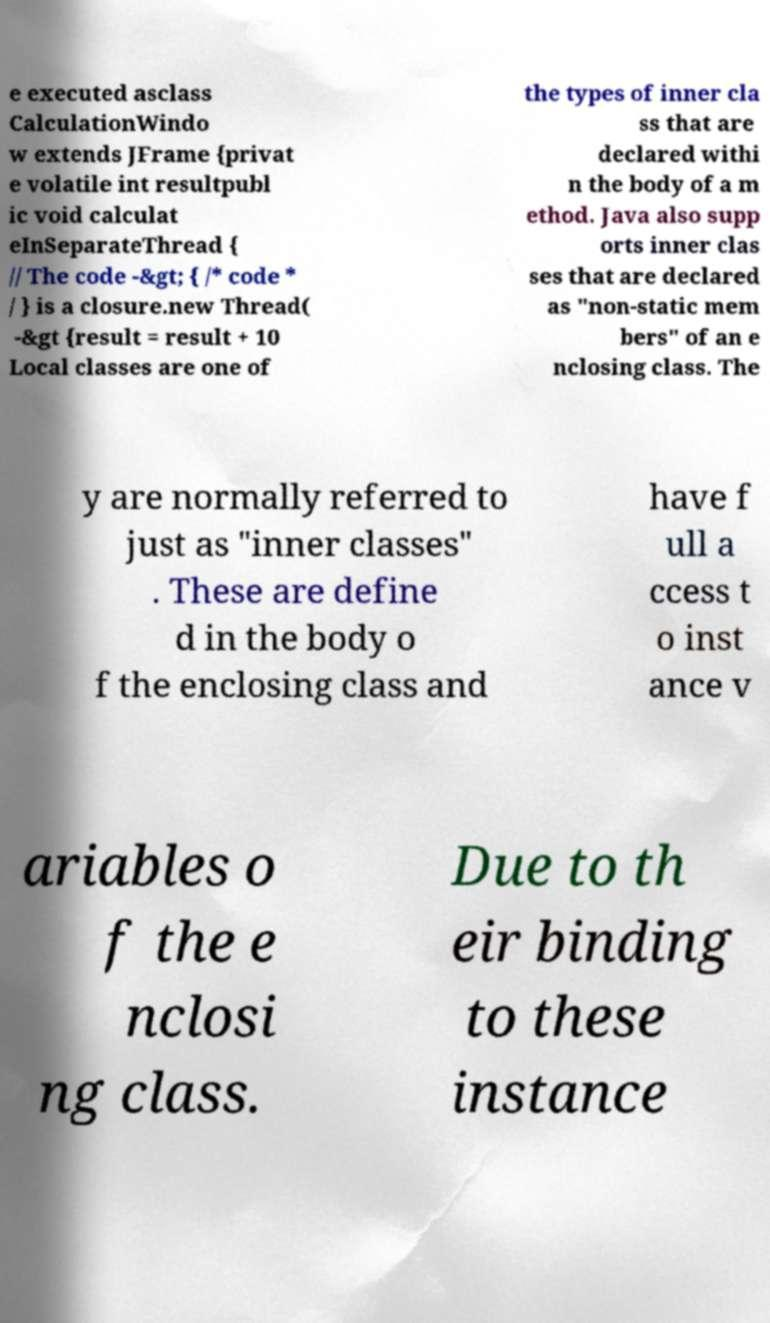Could you extract and type out the text from this image? e executed asclass CalculationWindo w extends JFrame {privat e volatile int resultpubl ic void calculat eInSeparateThread { // The code -&gt; { /* code * / } is a closure.new Thread( -&gt {result = result + 10 Local classes are one of the types of inner cla ss that are declared withi n the body of a m ethod. Java also supp orts inner clas ses that are declared as "non-static mem bers" of an e nclosing class. The y are normally referred to just as "inner classes" . These are define d in the body o f the enclosing class and have f ull a ccess t o inst ance v ariables o f the e nclosi ng class. Due to th eir binding to these instance 